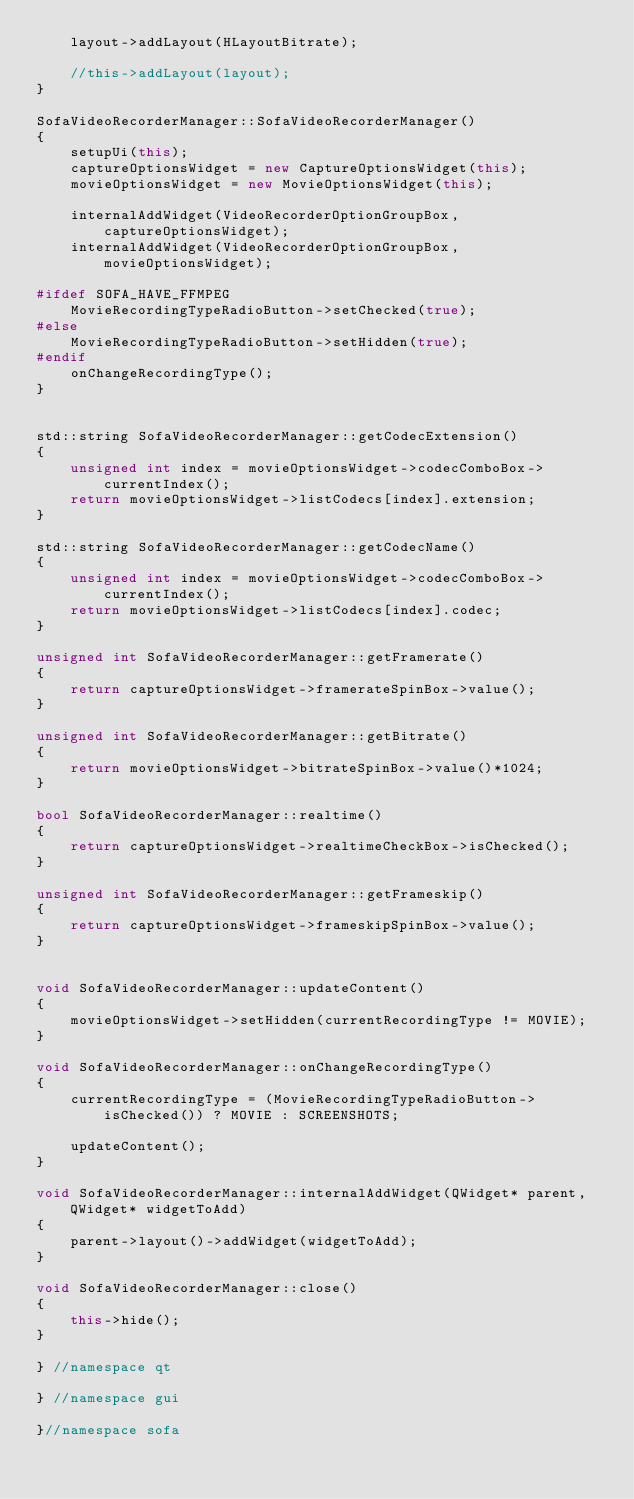Convert code to text. <code><loc_0><loc_0><loc_500><loc_500><_C++_>    layout->addLayout(HLayoutBitrate);

    //this->addLayout(layout);
}

SofaVideoRecorderManager::SofaVideoRecorderManager()
{
    setupUi(this);
    captureOptionsWidget = new CaptureOptionsWidget(this);
    movieOptionsWidget = new MovieOptionsWidget(this);

    internalAddWidget(VideoRecorderOptionGroupBox, captureOptionsWidget);
    internalAddWidget(VideoRecorderOptionGroupBox, movieOptionsWidget);

#ifdef SOFA_HAVE_FFMPEG
    MovieRecordingTypeRadioButton->setChecked(true);
#else
    MovieRecordingTypeRadioButton->setHidden(true);
#endif
    onChangeRecordingType();
}


std::string SofaVideoRecorderManager::getCodecExtension()
{
    unsigned int index = movieOptionsWidget->codecComboBox->currentIndex();
    return movieOptionsWidget->listCodecs[index].extension;
}

std::string SofaVideoRecorderManager::getCodecName()
{
    unsigned int index = movieOptionsWidget->codecComboBox->currentIndex();
    return movieOptionsWidget->listCodecs[index].codec;
}

unsigned int SofaVideoRecorderManager::getFramerate()
{
    return captureOptionsWidget->framerateSpinBox->value();
}

unsigned int SofaVideoRecorderManager::getBitrate()
{
    return movieOptionsWidget->bitrateSpinBox->value()*1024;
}

bool SofaVideoRecorderManager::realtime()
{
    return captureOptionsWidget->realtimeCheckBox->isChecked();
}

unsigned int SofaVideoRecorderManager::getFrameskip()
{
    return captureOptionsWidget->frameskipSpinBox->value();
}


void SofaVideoRecorderManager::updateContent()
{
    movieOptionsWidget->setHidden(currentRecordingType != MOVIE);
}

void SofaVideoRecorderManager::onChangeRecordingType()
{
    currentRecordingType = (MovieRecordingTypeRadioButton->isChecked()) ? MOVIE : SCREENSHOTS;

    updateContent();
}

void SofaVideoRecorderManager::internalAddWidget(QWidget* parent, QWidget* widgetToAdd)
{
    parent->layout()->addWidget(widgetToAdd);
}

void SofaVideoRecorderManager::close()
{
    this->hide();
}

} //namespace qt

} //namespace gui

}//namespace sofa
</code> 